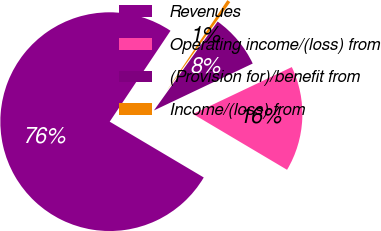Convert chart. <chart><loc_0><loc_0><loc_500><loc_500><pie_chart><fcel>Revenues<fcel>Operating income/(loss) from<fcel>(Provision for)/benefit from<fcel>Income/(loss) from<nl><fcel>75.86%<fcel>15.58%<fcel>8.05%<fcel>0.51%<nl></chart> 